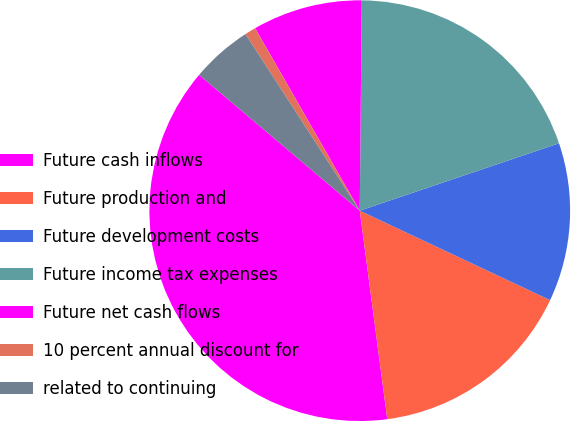<chart> <loc_0><loc_0><loc_500><loc_500><pie_chart><fcel>Future cash inflows<fcel>Future production and<fcel>Future development costs<fcel>Future income tax expenses<fcel>Future net cash flows<fcel>10 percent annual discount for<fcel>related to continuing<nl><fcel>38.26%<fcel>15.92%<fcel>12.18%<fcel>19.66%<fcel>8.44%<fcel>0.85%<fcel>4.69%<nl></chart> 